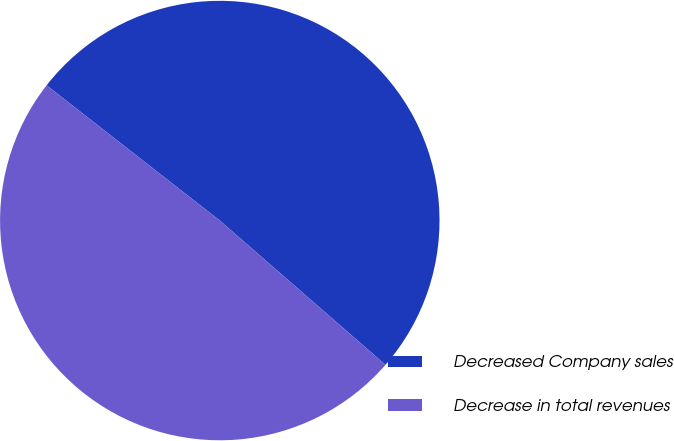Convert chart. <chart><loc_0><loc_0><loc_500><loc_500><pie_chart><fcel>Decreased Company sales<fcel>Decrease in total revenues<nl><fcel>50.85%<fcel>49.15%<nl></chart> 